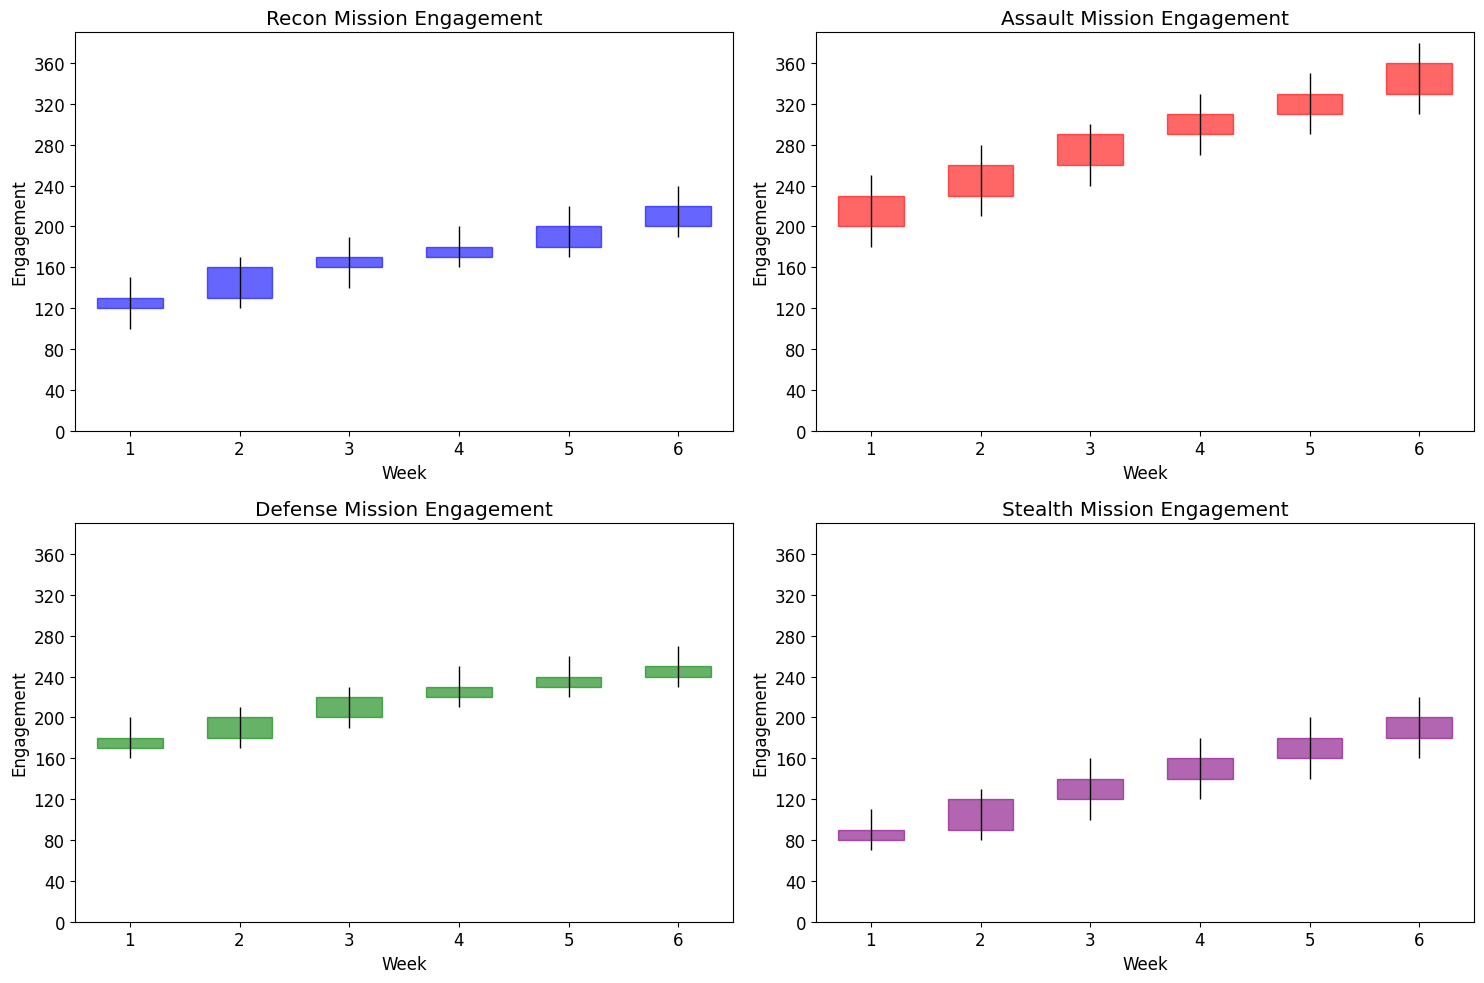Which mission had the highest engagement in Week 3? The red candlestick bars indicate the engagement for the Assault mission. In Week 3, the maximum value for the Assault mission is the highest among all missions.
Answer: Assault Which mission showed the most improvement in player engagement between Weeks 1 and 6? To determine improvement, we compare the closing values of Weeks 1 and 6 for each mission. Recon: 130 to 220 (+90), Assault: 230 to 360 (+130), Defense: 180 to 250 (+70), Stealth: 90 to 200 (+110). Assault mission had the highest improvement.
Answer: Assault What is the range of engagement (High minus Low) for the Stealth mission in Week 4? For the Stealth mission in Week 4, the high value is 180 and the low value is 120. The range is 180 - 120.
Answer: 60 Which mission had the lowest engagement at any point in Week 5? Looking at the low values in Week 5 for all missions: Recon (170), Assault (290), Defense (220), Stealth (140), Stealth had the lowest value.
Answer: Stealth Which missions experienced a decline in engagement from Week 5 to Week 6? We observe a decline by comparing closing values of Week 5 and Week 6: Recon: 200 to 220 (increase), Assault: 330 to 360 (increase), Defense: 240 to 250 (increase), Stealth: 180 to 200 (increase). None of the missions experienced a decline.
Answer: None What is the average closing engagement in Week 2 for all missions? Add the closing values for all missions in Week 2 and divide by the number of missions: (160 + 260 + 200 + 120) / 4.
Answer: 185 Which mission had a greater increase in engagement from Week 1 to Week 3: Recon or Defense? We compare the differences in closing values from Week 1 to Week 3: Recon: 170 - 130 = 40, Defense: 220 - 180 = 40, so both had an equal increase.
Answer: Equal How does the extent of fluctuation in engagement for the Assault mission in Week 4 compare to Week 6? For Week 4, the range (high - low) is 330 - 270 = 60. For Week 6, it is 380 - 310 = 70. The fluctuation in Week 6 is greater.
Answer: Greater in Week 6 What is the median closing engagement for all missions in Week 4? Sort the closing values of Week 4 missions: 160, 180, 230, 310. The median is the average of the two middle numbers (180 + 230) / 2.
Answer: 205 Which mission displayed the most consistent engagement across the 6 weeks? Consistency can be measured by similarity in closing values. Reviewing all missions, Defense showed the least variation in closing values (180, 200, 220, 230, 240, 250).
Answer: Defense 